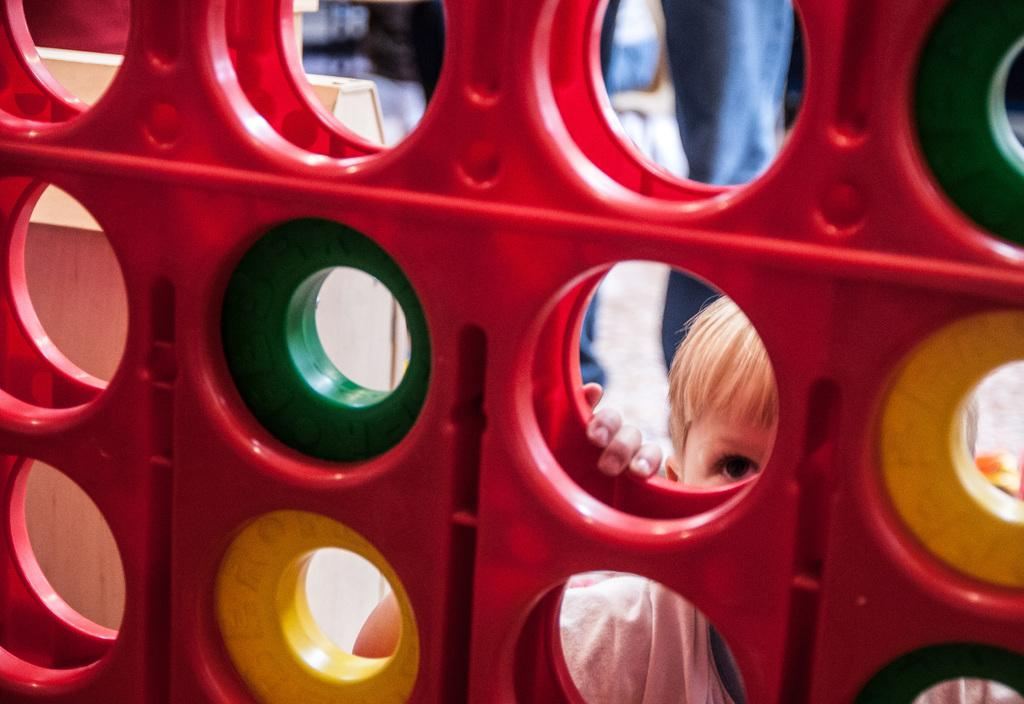What is present in the image? There is a wall in the image. What is the boy doing in the image? A boy is standing behind the wall and watching. Can you describe the person behind the boy? There is a person standing behind the boy. What type of insurance policy is the boy discussing with the person behind him? There is no mention of insurance or any discussion in the image. 